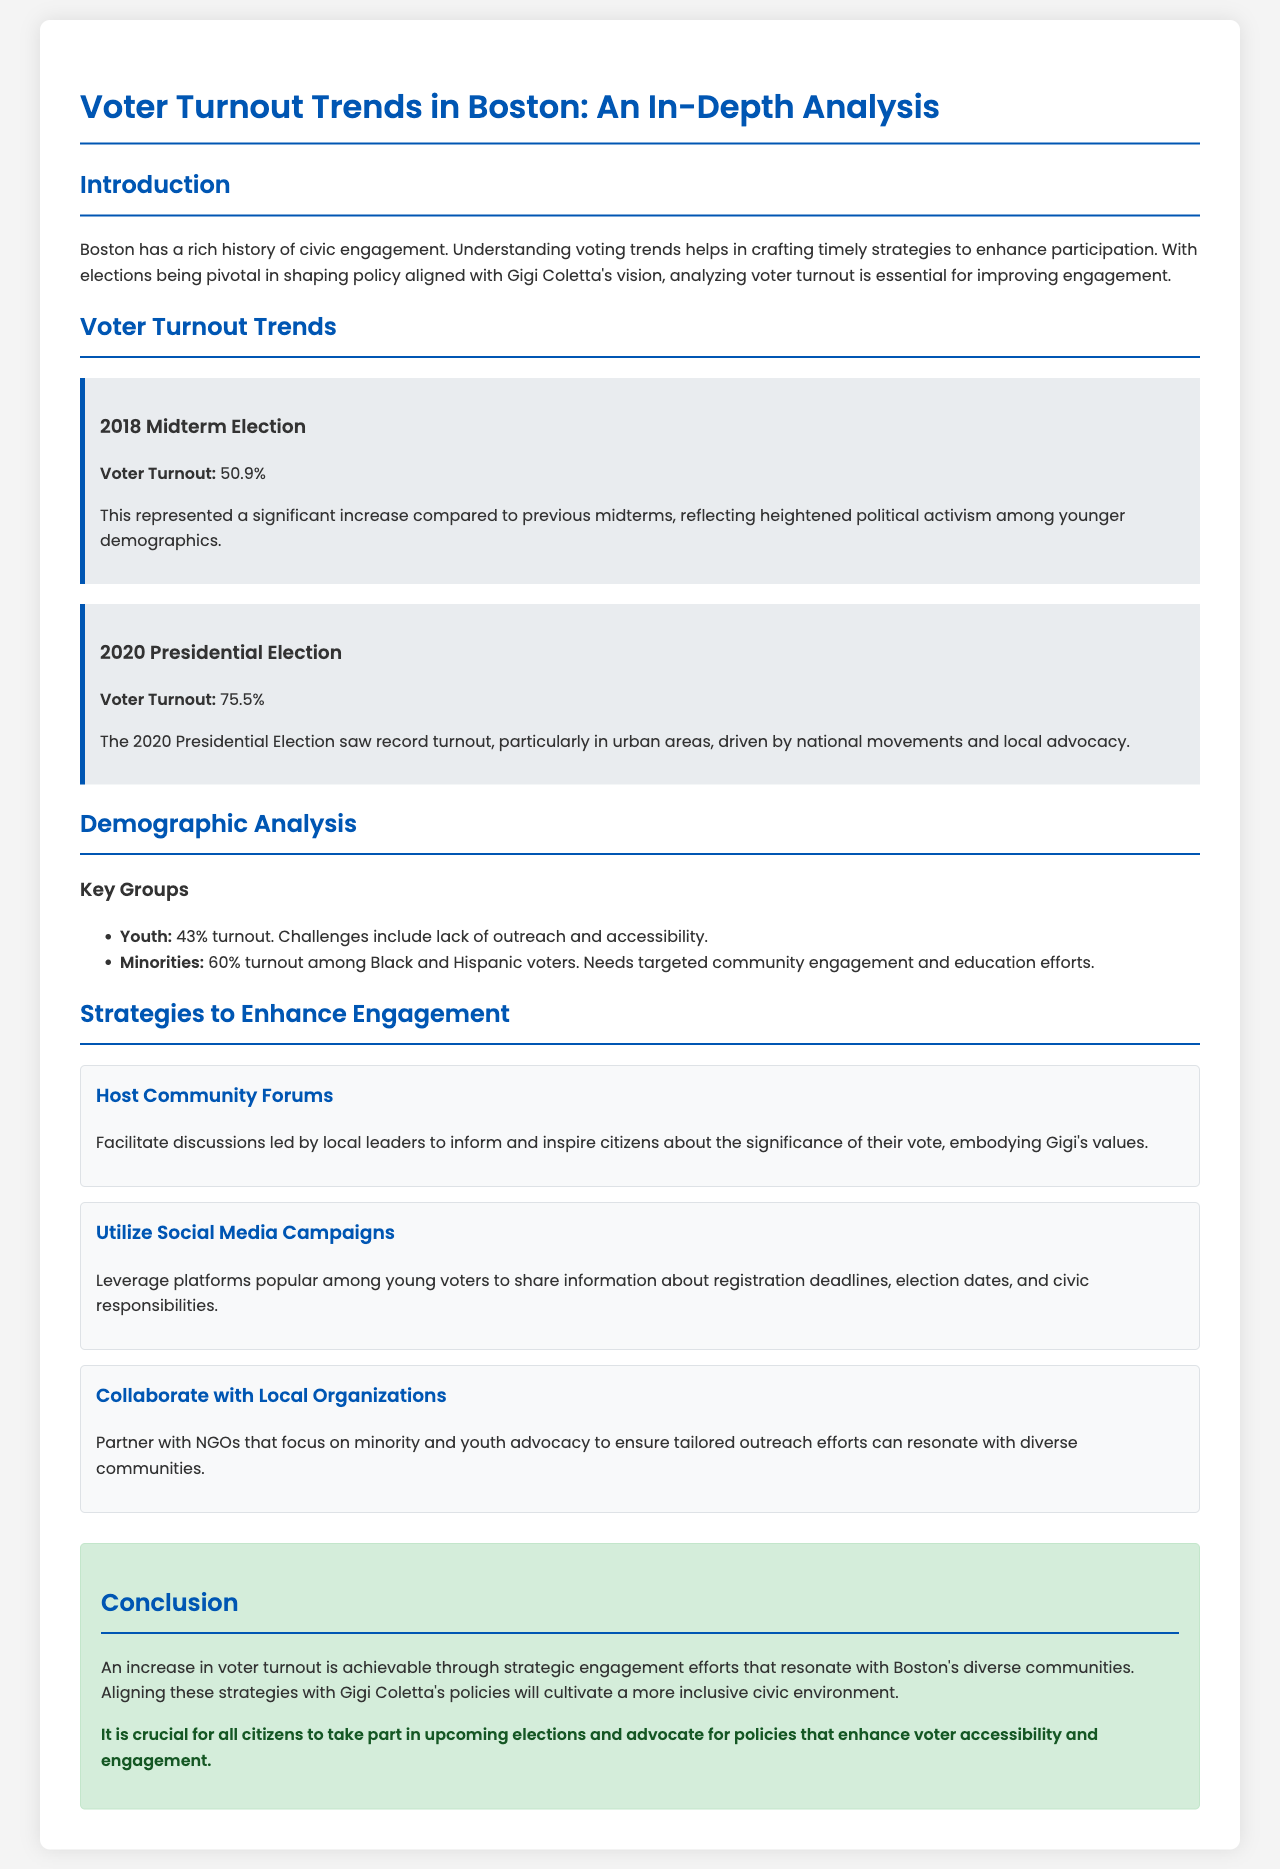What was the voter turnout in the 2018 Midterm Election? The document states that the voter turnout for the 2018 Midterm Election was significantly increased, with a total of 50.9%.
Answer: 50.9% What was the voter turnout in the 2020 Presidential Election? According to the document, the voter turnout for the 2020 Presidential Election reached record levels at 75.5%.
Answer: 75.5% What percentage of youth turned out to vote? The document mentions that 43% of youth participated in the election.
Answer: 43% What is one of the strategies to enhance civic engagement mentioned in the report? The report outlines various strategies, and one of them is to host community forums to inform citizens about voting.
Answer: Host Community Forums Which demographic group had a turnout of 60%? The document indicates that Black and Hispanic voters made up this demographic group with a 60% turnout.
Answer: Black and Hispanic voters What is the call to action in the conclusion section? The conclusion highlights the crucial need for citizens to participate in upcoming elections and advocate for voter accessibility and engagement.
Answer: Advocate for policies What does the report suggest is essential for improving civic engagement? The report emphasizes that understanding voting trends is essential for crafting strategies to enhance participation in elections.
Answer: Understanding voting trends What year had a significant increase in political activism among younger demographics according to the trends? The document specifies that the 2018 Midterm Election saw a significant increase in activism among younger demographics.
Answer: 2018 Midterm Election 